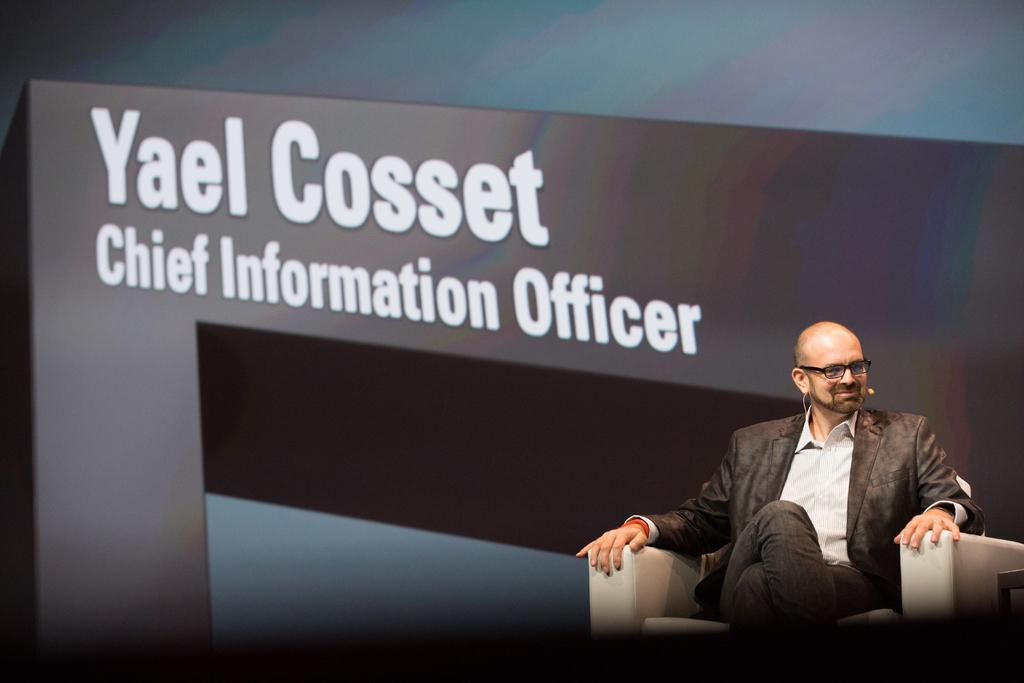Who is present in the image? There is a man in the image. What is the man wearing? The man is wearing a blazer and spectacles. What is the man's posture in the image? The man is sitting on a chair. What is the man's facial expression in the image? The man is smiling. What can be seen in the background of the image? There is a banner in the background of the image. Can you see a goldfish swimming in the image? No, there is no goldfish present in the image. 